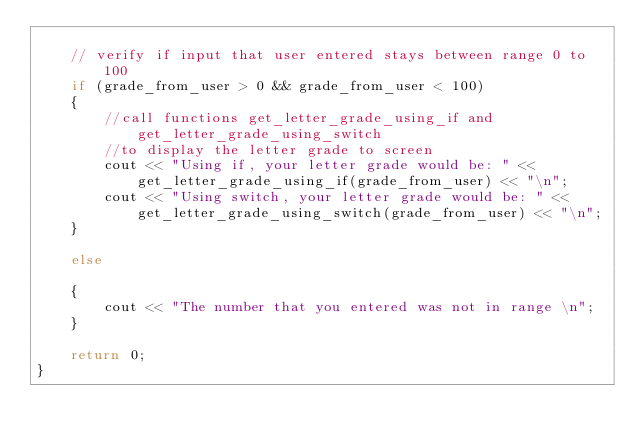<code> <loc_0><loc_0><loc_500><loc_500><_C++_>
	// verify if input that user entered stays between range 0 to 100
	if (grade_from_user > 0 && grade_from_user < 100)
	{
		//call functions get_letter_grade_using_if and get_letter_grade_using_switch 
		//to display the letter grade to screen
		cout << "Using if, your letter grade would be: " << get_letter_grade_using_if(grade_from_user) << "\n";
		cout << "Using switch, your letter grade would be: " << get_letter_grade_using_switch(grade_from_user) << "\n";
	}
	
	else

	{
		cout << "The number that you entered was not in range \n";
	}

	return 0;
}

</code> 